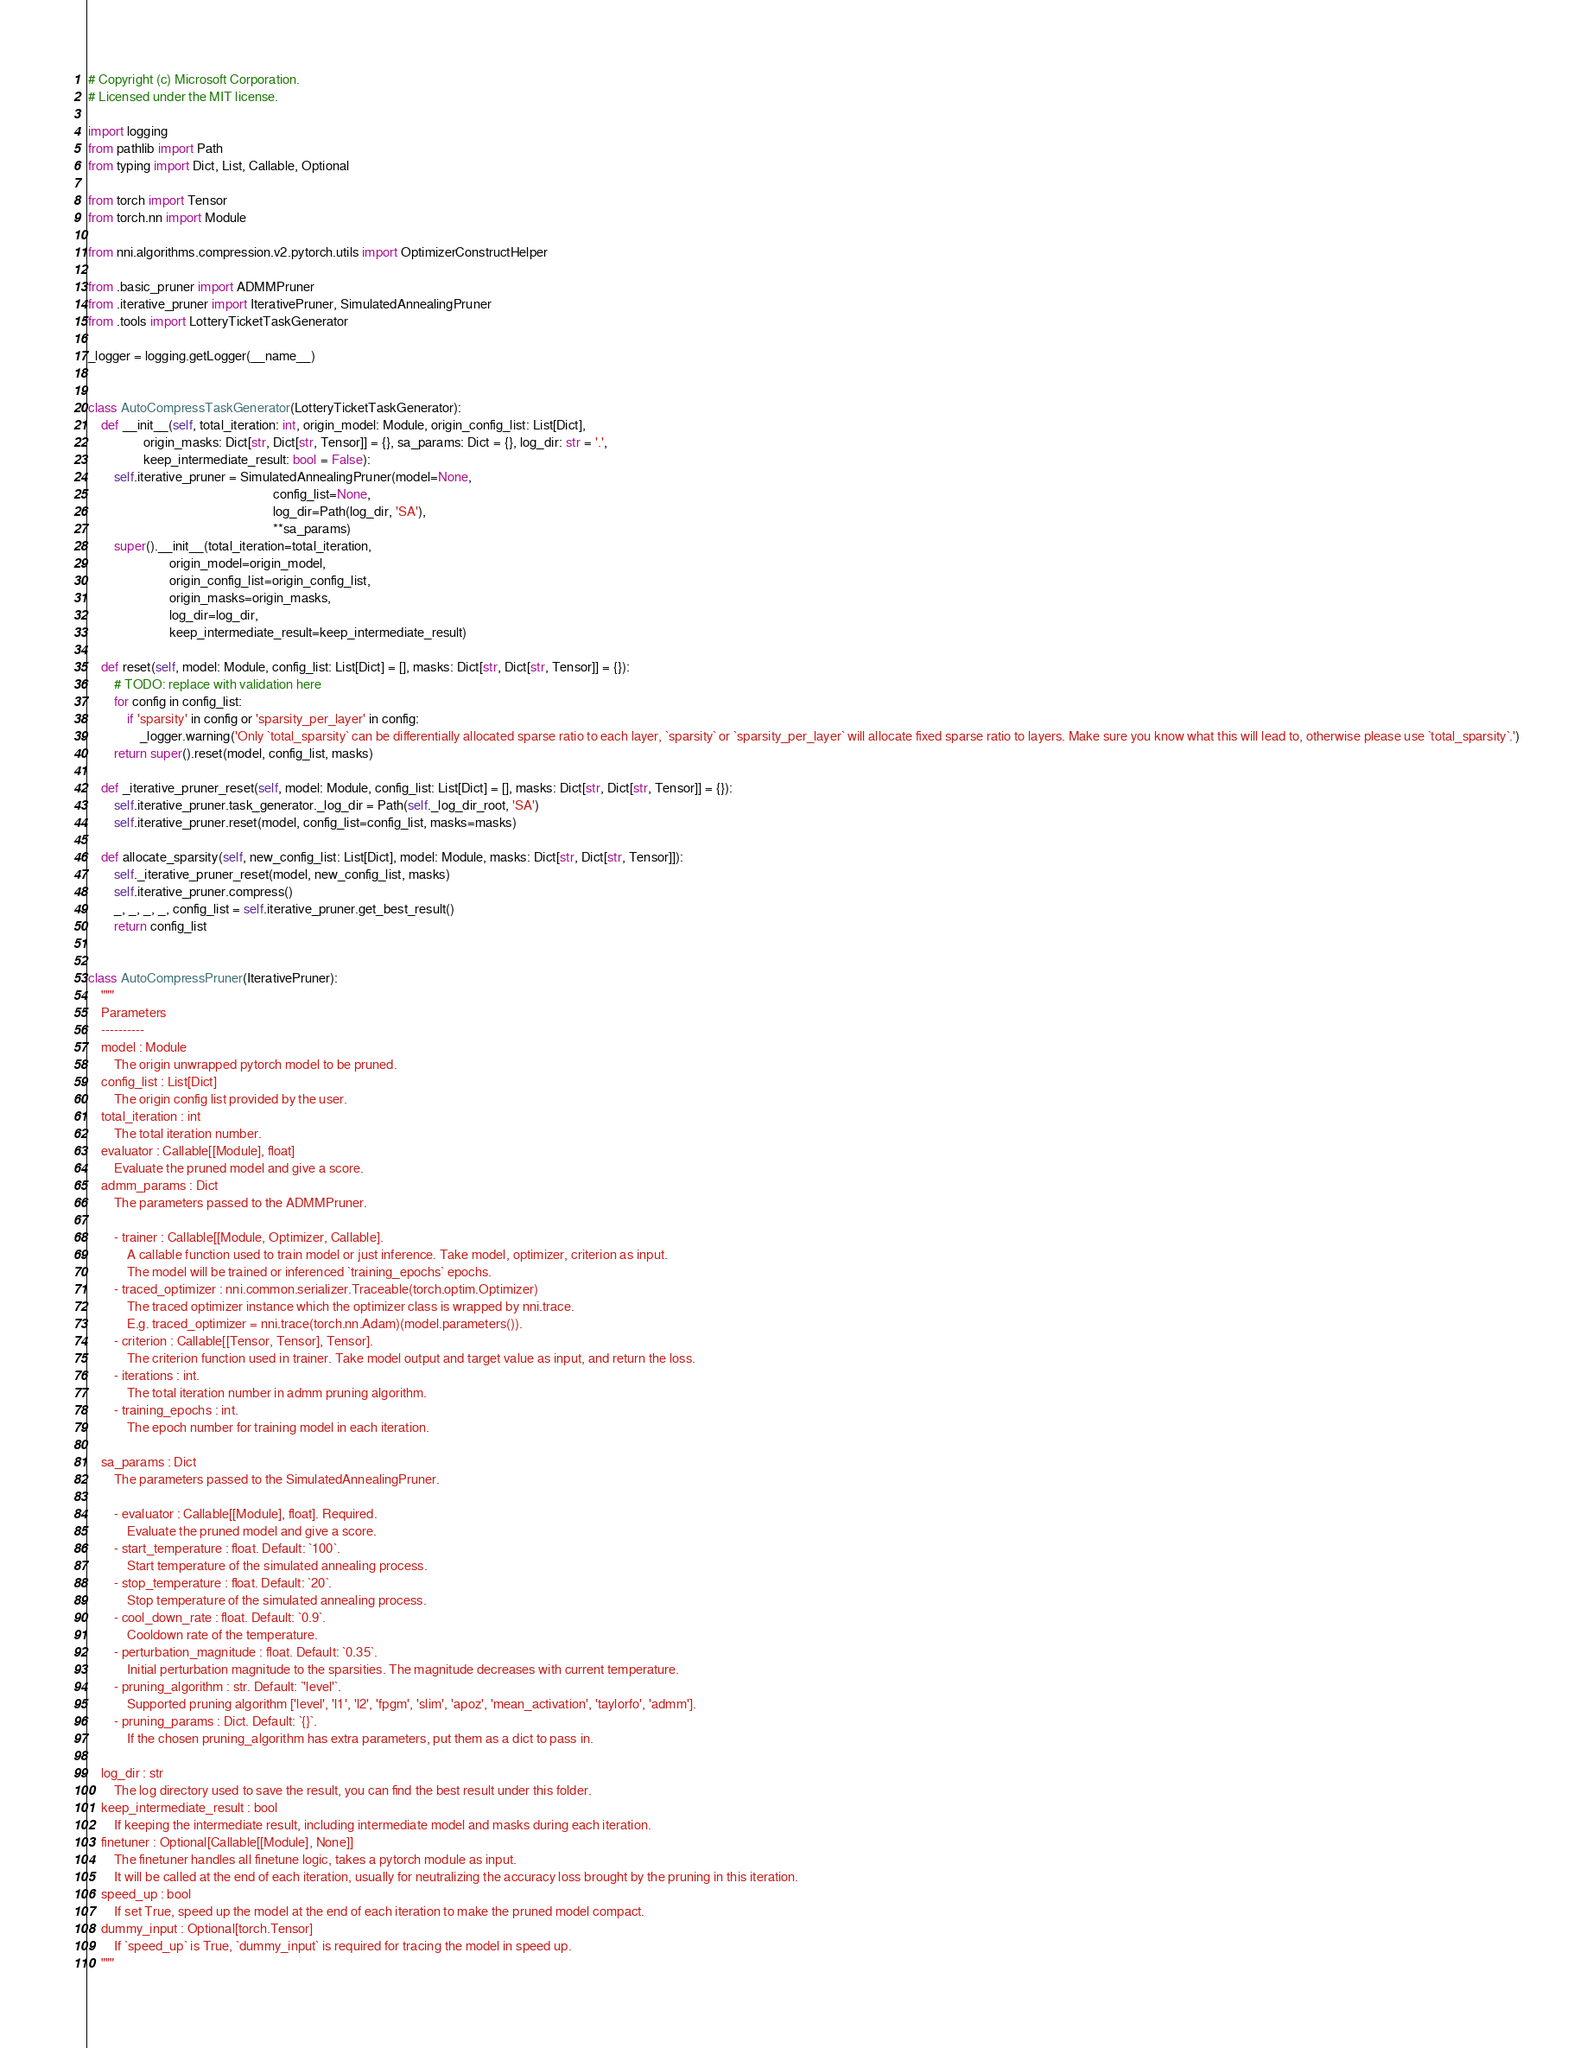Convert code to text. <code><loc_0><loc_0><loc_500><loc_500><_Python_># Copyright (c) Microsoft Corporation.
# Licensed under the MIT license.

import logging
from pathlib import Path
from typing import Dict, List, Callable, Optional

from torch import Tensor
from torch.nn import Module

from nni.algorithms.compression.v2.pytorch.utils import OptimizerConstructHelper

from .basic_pruner import ADMMPruner
from .iterative_pruner import IterativePruner, SimulatedAnnealingPruner
from .tools import LotteryTicketTaskGenerator

_logger = logging.getLogger(__name__)


class AutoCompressTaskGenerator(LotteryTicketTaskGenerator):
    def __init__(self, total_iteration: int, origin_model: Module, origin_config_list: List[Dict],
                 origin_masks: Dict[str, Dict[str, Tensor]] = {}, sa_params: Dict = {}, log_dir: str = '.',
                 keep_intermediate_result: bool = False):
        self.iterative_pruner = SimulatedAnnealingPruner(model=None,
                                                         config_list=None,
                                                         log_dir=Path(log_dir, 'SA'),
                                                         **sa_params)
        super().__init__(total_iteration=total_iteration,
                         origin_model=origin_model,
                         origin_config_list=origin_config_list,
                         origin_masks=origin_masks,
                         log_dir=log_dir,
                         keep_intermediate_result=keep_intermediate_result)

    def reset(self, model: Module, config_list: List[Dict] = [], masks: Dict[str, Dict[str, Tensor]] = {}):
        # TODO: replace with validation here
        for config in config_list:
            if 'sparsity' in config or 'sparsity_per_layer' in config:
                _logger.warning('Only `total_sparsity` can be differentially allocated sparse ratio to each layer, `sparsity` or `sparsity_per_layer` will allocate fixed sparse ratio to layers. Make sure you know what this will lead to, otherwise please use `total_sparsity`.')
        return super().reset(model, config_list, masks)

    def _iterative_pruner_reset(self, model: Module, config_list: List[Dict] = [], masks: Dict[str, Dict[str, Tensor]] = {}):
        self.iterative_pruner.task_generator._log_dir = Path(self._log_dir_root, 'SA')
        self.iterative_pruner.reset(model, config_list=config_list, masks=masks)

    def allocate_sparsity(self, new_config_list: List[Dict], model: Module, masks: Dict[str, Dict[str, Tensor]]):
        self._iterative_pruner_reset(model, new_config_list, masks)
        self.iterative_pruner.compress()
        _, _, _, _, config_list = self.iterative_pruner.get_best_result()
        return config_list


class AutoCompressPruner(IterativePruner):
    """
    Parameters
    ----------
    model : Module
        The origin unwrapped pytorch model to be pruned.
    config_list : List[Dict]
        The origin config list provided by the user.
    total_iteration : int
        The total iteration number.
    evaluator : Callable[[Module], float]
        Evaluate the pruned model and give a score.
    admm_params : Dict
        The parameters passed to the ADMMPruner.

        - trainer : Callable[[Module, Optimizer, Callable].
            A callable function used to train model or just inference. Take model, optimizer, criterion as input.
            The model will be trained or inferenced `training_epochs` epochs.
        - traced_optimizer : nni.common.serializer.Traceable(torch.optim.Optimizer)
            The traced optimizer instance which the optimizer class is wrapped by nni.trace.
            E.g. traced_optimizer = nni.trace(torch.nn.Adam)(model.parameters()).
        - criterion : Callable[[Tensor, Tensor], Tensor].
            The criterion function used in trainer. Take model output and target value as input, and return the loss.
        - iterations : int.
            The total iteration number in admm pruning algorithm.
        - training_epochs : int.
            The epoch number for training model in each iteration.

    sa_params : Dict
        The parameters passed to the SimulatedAnnealingPruner.

        - evaluator : Callable[[Module], float]. Required.
            Evaluate the pruned model and give a score.
        - start_temperature : float. Default: `100`.
            Start temperature of the simulated annealing process.
        - stop_temperature : float. Default: `20`.
            Stop temperature of the simulated annealing process.
        - cool_down_rate : float. Default: `0.9`.
            Cooldown rate of the temperature.
        - perturbation_magnitude : float. Default: `0.35`.
            Initial perturbation magnitude to the sparsities. The magnitude decreases with current temperature.
        - pruning_algorithm : str. Default: `'level'`.
            Supported pruning algorithm ['level', 'l1', 'l2', 'fpgm', 'slim', 'apoz', 'mean_activation', 'taylorfo', 'admm'].
        - pruning_params : Dict. Default: `{}`.
            If the chosen pruning_algorithm has extra parameters, put them as a dict to pass in.

    log_dir : str
        The log directory used to save the result, you can find the best result under this folder.
    keep_intermediate_result : bool
        If keeping the intermediate result, including intermediate model and masks during each iteration.
    finetuner : Optional[Callable[[Module], None]]
        The finetuner handles all finetune logic, takes a pytorch module as input.
        It will be called at the end of each iteration, usually for neutralizing the accuracy loss brought by the pruning in this iteration.
    speed_up : bool
        If set True, speed up the model at the end of each iteration to make the pruned model compact.
    dummy_input : Optional[torch.Tensor]
        If `speed_up` is True, `dummy_input` is required for tracing the model in speed up.
    """
</code> 